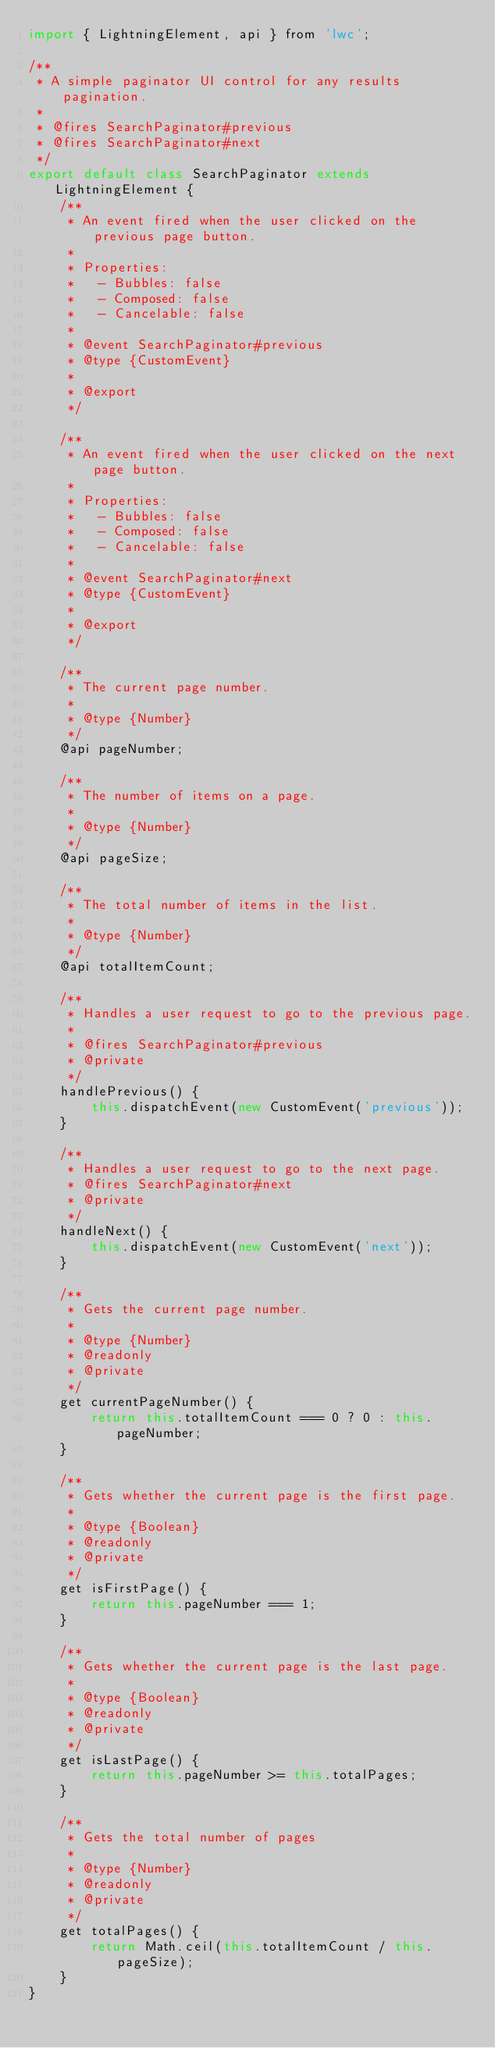<code> <loc_0><loc_0><loc_500><loc_500><_JavaScript_>import { LightningElement, api } from 'lwc';

/**
 * A simple paginator UI control for any results pagination.
 *
 * @fires SearchPaginator#previous
 * @fires SearchPaginator#next
 */
export default class SearchPaginator extends LightningElement {
    /**
     * An event fired when the user clicked on the previous page button.
     *
     * Properties:
     *   - Bubbles: false
     *   - Composed: false
     *   - Cancelable: false
     *
     * @event SearchPaginator#previous
     * @type {CustomEvent}
     *
     * @export
     */

    /**
     * An event fired when the user clicked on the next page button.
     *
     * Properties:
     *   - Bubbles: false
     *   - Composed: false
     *   - Cancelable: false
     *
     * @event SearchPaginator#next
     * @type {CustomEvent}
     *
     * @export
     */

    /**
     * The current page number.
     *
     * @type {Number}
     */
    @api pageNumber;

    /**
     * The number of items on a page.
     *
     * @type {Number}
     */
    @api pageSize;

    /**
     * The total number of items in the list.
     *
     * @type {Number}
     */
    @api totalItemCount;

    /**
     * Handles a user request to go to the previous page.
     *
     * @fires SearchPaginator#previous
     * @private
     */
    handlePrevious() {
        this.dispatchEvent(new CustomEvent('previous'));
    }

    /**
     * Handles a user request to go to the next page.
     * @fires SearchPaginator#next
     * @private
     */
    handleNext() {
        this.dispatchEvent(new CustomEvent('next'));
    }

    /**
     * Gets the current page number.
     *
     * @type {Number}
     * @readonly
     * @private
     */
    get currentPageNumber() {
        return this.totalItemCount === 0 ? 0 : this.pageNumber;
    }

    /**
     * Gets whether the current page is the first page.
     *
     * @type {Boolean}
     * @readonly
     * @private
     */
    get isFirstPage() {
        return this.pageNumber === 1;
    }

    /**
     * Gets whether the current page is the last page.
     *
     * @type {Boolean}
     * @readonly
     * @private
     */
    get isLastPage() {
        return this.pageNumber >= this.totalPages;
    }

    /**
     * Gets the total number of pages
     *
     * @type {Number}
     * @readonly
     * @private
     */
    get totalPages() {
        return Math.ceil(this.totalItemCount / this.pageSize);
    }
}
</code> 